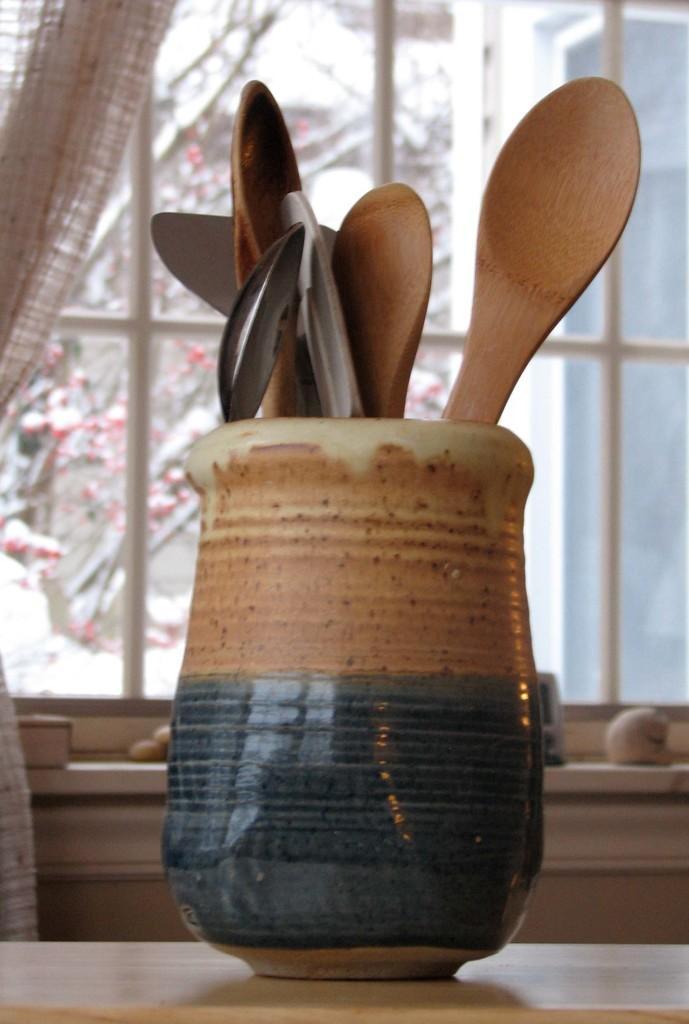Describe this image in one or two sentences. As we can see in the image there is window and table. On table there is flask. In flask there are spoons. Outside the window there is tree. 